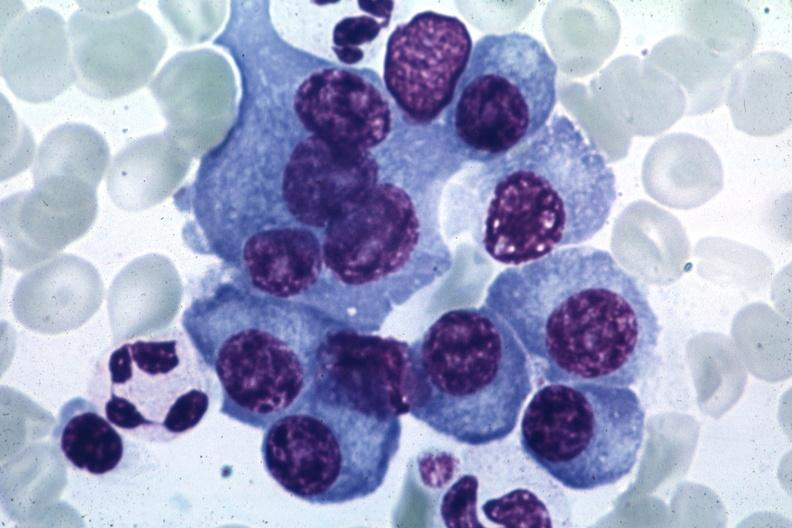s bone marrow present?
Answer the question using a single word or phrase. Yes 